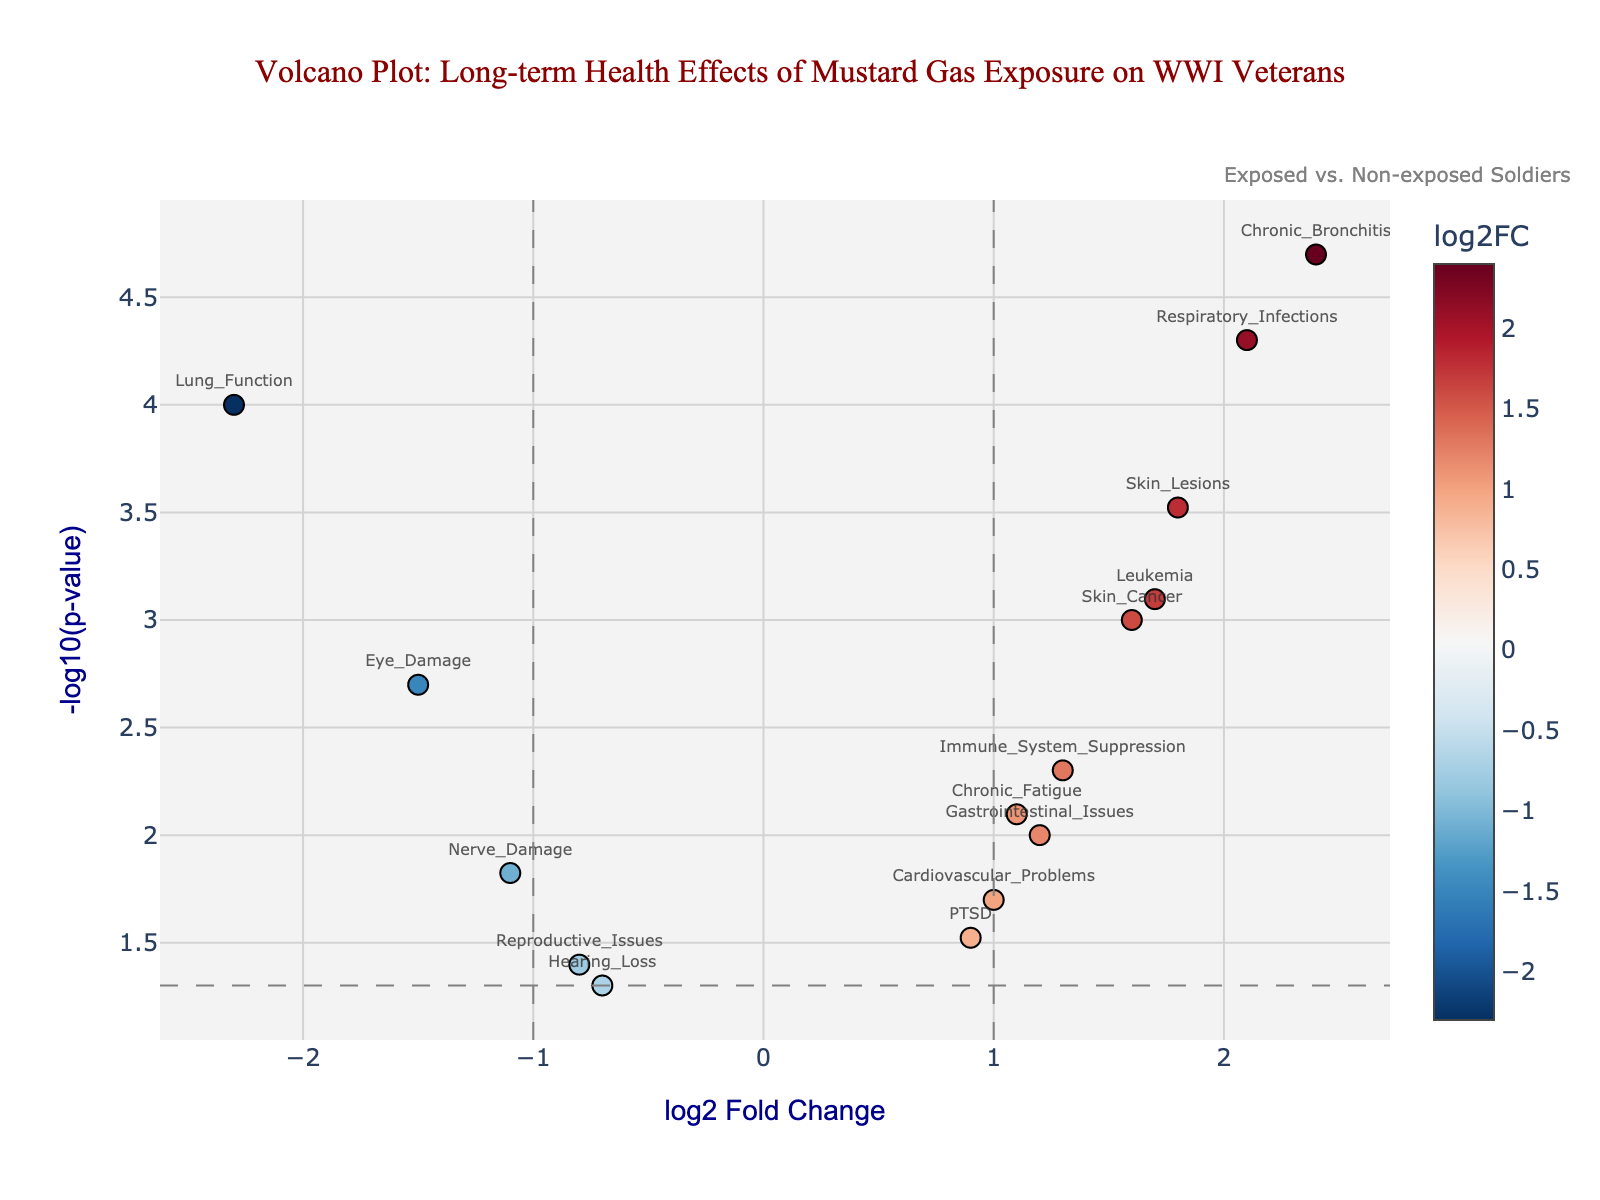How many data points are displayed in the plot? Count the number of markers shown on the plot, each representing a different gene with associated log2FoldChange and -log10(p-value).
Answer: 14 What does a positive log2 Fold Change indicate about the health effect? A positive log2 Fold Change indicates that the health effect is more prevalent in exposed soldiers compared to non-exposed soldiers.
Answer: More prevalent in exposed soldiers Which health condition shows the largest positive log2 Fold Change? Identify the marker farthest to the right on the x-axis, which represents the highest positive log2 Fold Change. The gene label of this marker reveals the health condition.
Answer: Chronic_Bronchitis What is the significance of a gene falling above the horizontal threshold line at -log10(p-value)=1.3? Any gene above this line has a p-value less than 0.05, indicating statistically significant differences between exposed and non-exposed soldiers.
Answer: Statistically significant differences Which genes have a statistically significant negative log2 Fold Change? Find genes above the horizontal threshold line (-log10(p-value) > 1.3) and left of the vertical threshold line (log2FoldChange < -1).
Answer: Lung_Function and Eye_Damage Compare the significance levels of Respiratory_Infections and Leukemia. Which one is higher? Check the -log10(p-value) for both genes. The gene with the higher -log10(p-value) has the greater significance level.
Answer: Respiratory_Infections Which health condition has the lowest p-value? Look for the data point with the highest -log10(p-value) value, as this would correspond to the smallest p-value. The gene label of this point reveals the health condition.
Answer: Chronic_Bronchitis What are the log2 Fold Change and p-value for Skin_Lesions? Locate the marker labeled "Skin_Lesions" and read the hover text or annotations which describe the log2 Fold Change and p-value.
Answer: log2FC: 1.8, p-value: 0.0003 What does it mean if a health condition is located to the far left but does not cross the significance threshold? A gene with a negative log2 Fold Change to the left but below the horizontal significance line indicates a trending but not statistically significant decrease in the health issue among exposed soldiers compared to non-exposed soldiers.
Answer: Trending but not statistically significant decrease 